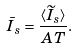<formula> <loc_0><loc_0><loc_500><loc_500>\bar { I } _ { s } = \frac { \langle \widetilde { I } _ { s } \rangle } { A T } .</formula> 